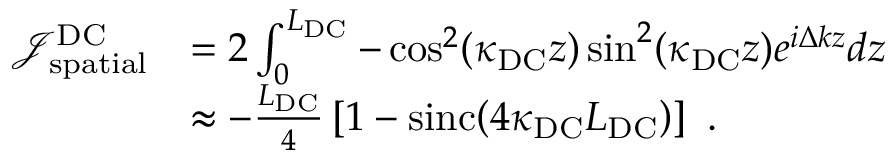Convert formula to latex. <formula><loc_0><loc_0><loc_500><loc_500>\begin{array} { r l } { \mathcal { J } _ { s p a t i a l } ^ { D C } } & { = 2 \int _ { 0 } ^ { L _ { D C } } - \cos ^ { 2 } ( \kappa _ { D C } z ) \sin ^ { 2 } ( \kappa _ { D C } z ) e ^ { i \Delta k z } d z } \\ & { \approx - \frac { L _ { D C } } { 4 } \left [ 1 - \sin c \, \left ( 4 \kappa _ { D C } L _ { D C } \right ) \right ] \ . } \end{array}</formula> 